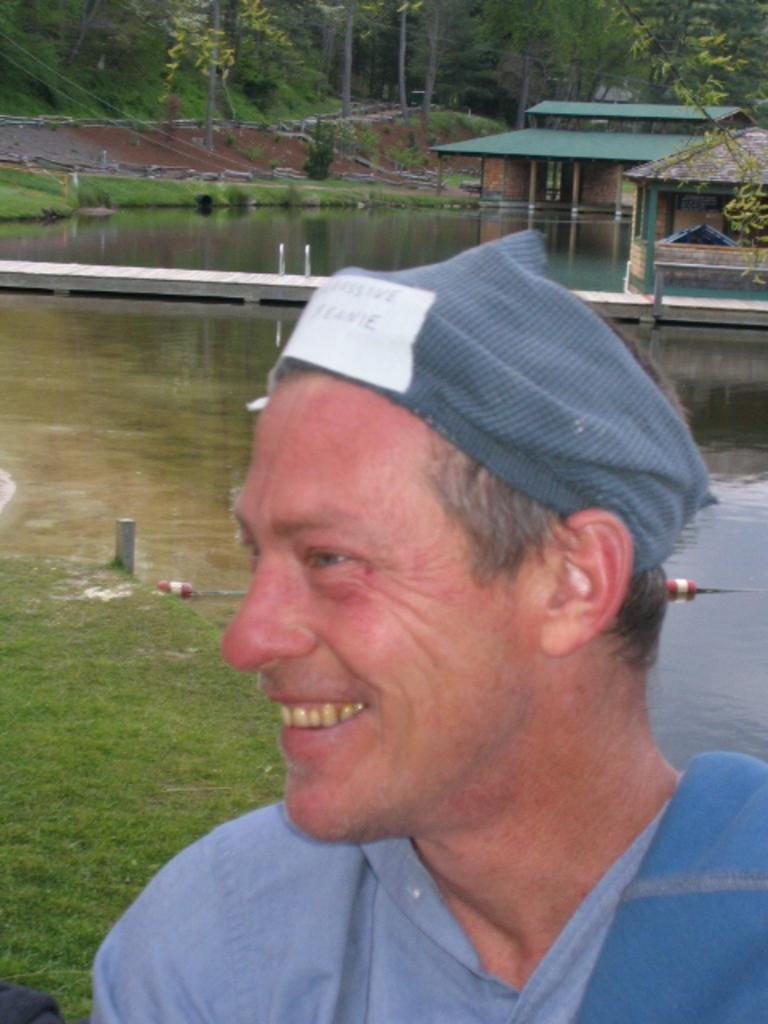Who is present in the image? There is a man in the image. What is the man's expression? The man is smiling. What can be seen in the background of the image? There is a lake, wooden houses, and trees in the background of the image. What type of glue is the man using to stick the spoon to his forehead in the image? There is no glue or spoon present in the image, and therefore no such activity can be observed. 